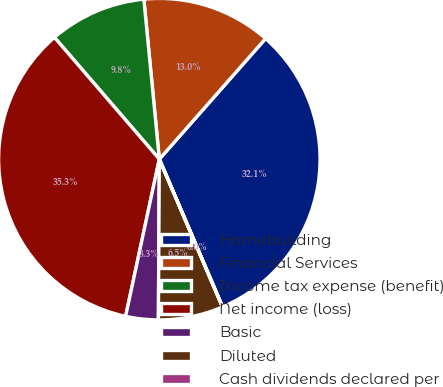Convert chart to OTSL. <chart><loc_0><loc_0><loc_500><loc_500><pie_chart><fcel>Homebuilding<fcel>Financial Services<fcel>Income tax expense (benefit)<fcel>Net income (loss)<fcel>Basic<fcel>Diluted<fcel>Cash dividends declared per<nl><fcel>32.07%<fcel>13.03%<fcel>9.78%<fcel>35.32%<fcel>3.27%<fcel>6.52%<fcel>0.01%<nl></chart> 